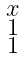Convert formula to latex. <formula><loc_0><loc_0><loc_500><loc_500>\begin{smallmatrix} x \\ 1 \\ 1 \end{smallmatrix}</formula> 